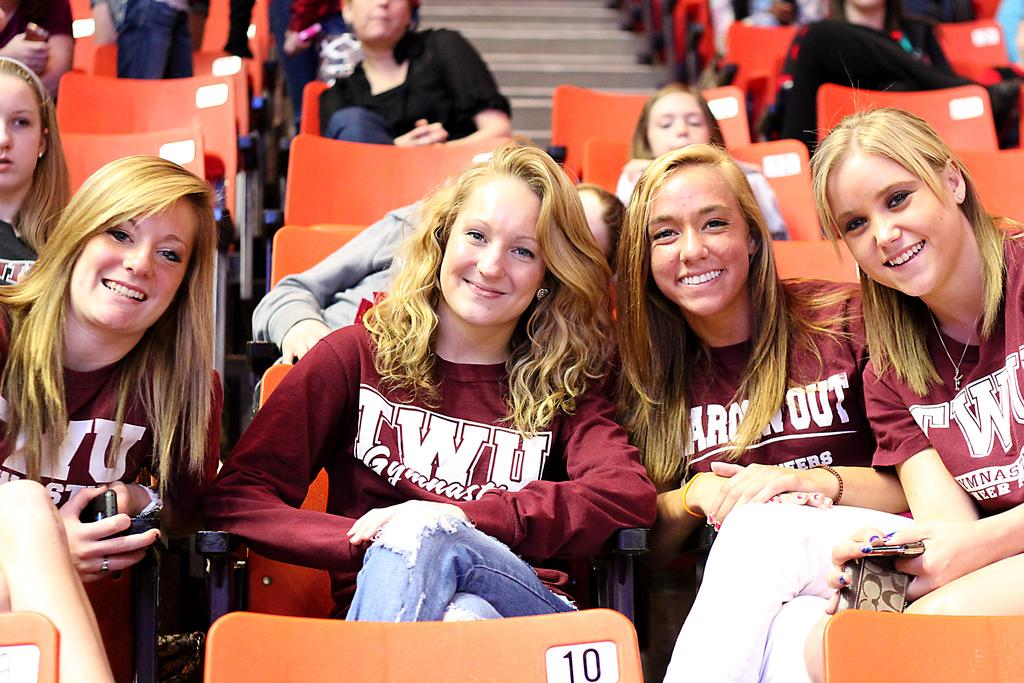What is happening in the image involving a group of people? There is a group of people in the image, and they are sitting in chairs. What are the people holding in their hands? The people are holding mobile phones in their hands. What can be seen in the background of the image? There is a staircase in the background of the image. What type of roll can be seen being used by the people in the image? There is no roll present in the image; the people are holding mobile phones. What is the purpose of the rake in the image? There is no rake present in the image. 